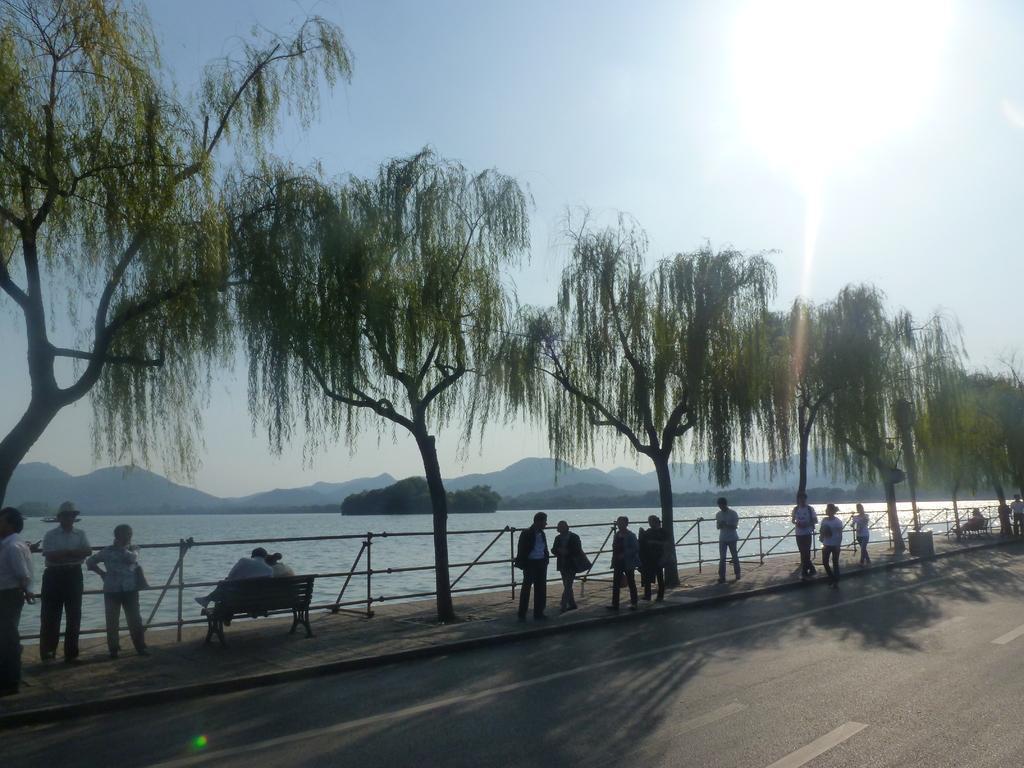In one or two sentences, can you explain what this image depicts? In this image we can see group of persons on the footpath. At the bottom of the image there is a road. In the background there are hills, water and sky. 